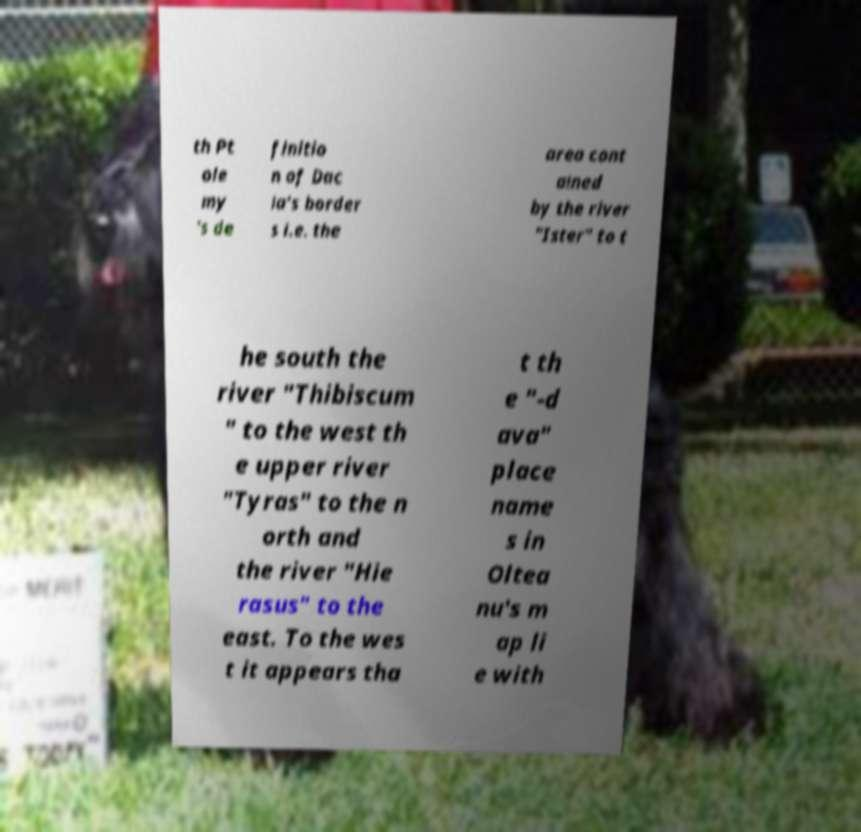Could you extract and type out the text from this image? th Pt ole my 's de finitio n of Dac ia's border s i.e. the area cont ained by the river "Ister" to t he south the river "Thibiscum " to the west th e upper river "Tyras" to the n orth and the river "Hie rasus" to the east. To the wes t it appears tha t th e "-d ava" place name s in Oltea nu's m ap li e with 